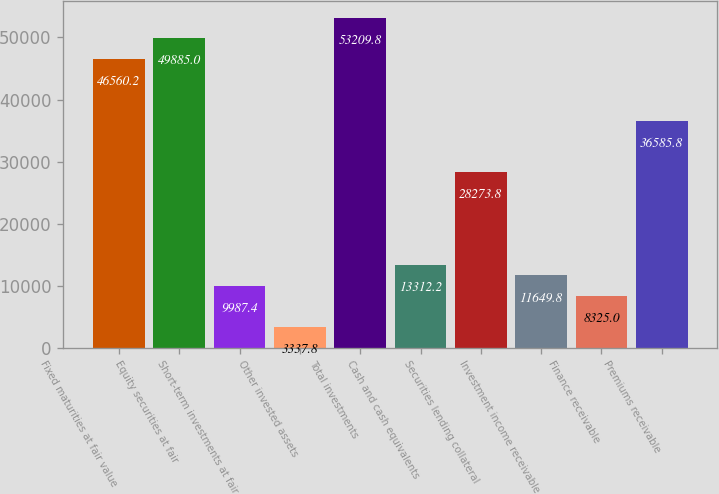<chart> <loc_0><loc_0><loc_500><loc_500><bar_chart><fcel>Fixed maturities at fair value<fcel>Equity securities at fair<fcel>Short-term investments at fair<fcel>Other invested assets<fcel>Total investments<fcel>Cash and cash equivalents<fcel>Securities lending collateral<fcel>Investment income receivable<fcel>Finance receivable<fcel>Premiums receivable<nl><fcel>46560.2<fcel>49885<fcel>9987.4<fcel>3337.8<fcel>53209.8<fcel>13312.2<fcel>28273.8<fcel>11649.8<fcel>8325<fcel>36585.8<nl></chart> 